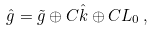<formula> <loc_0><loc_0><loc_500><loc_500>\hat { g } = \tilde { g } \oplus C \hat { k } \oplus C L _ { 0 } \, ,</formula> 